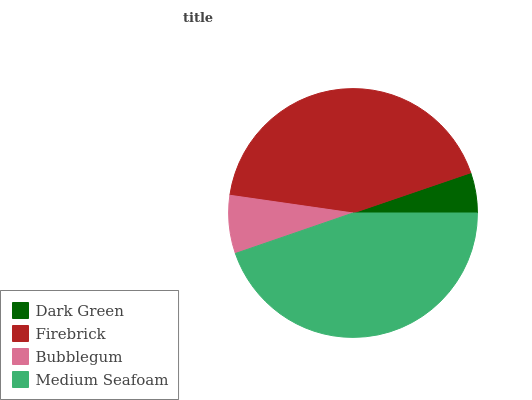Is Dark Green the minimum?
Answer yes or no. Yes. Is Medium Seafoam the maximum?
Answer yes or no. Yes. Is Firebrick the minimum?
Answer yes or no. No. Is Firebrick the maximum?
Answer yes or no. No. Is Firebrick greater than Dark Green?
Answer yes or no. Yes. Is Dark Green less than Firebrick?
Answer yes or no. Yes. Is Dark Green greater than Firebrick?
Answer yes or no. No. Is Firebrick less than Dark Green?
Answer yes or no. No. Is Firebrick the high median?
Answer yes or no. Yes. Is Bubblegum the low median?
Answer yes or no. Yes. Is Bubblegum the high median?
Answer yes or no. No. Is Firebrick the low median?
Answer yes or no. No. 